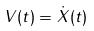Convert formula to latex. <formula><loc_0><loc_0><loc_500><loc_500>V ( t ) = \dot { X } ( t )</formula> 